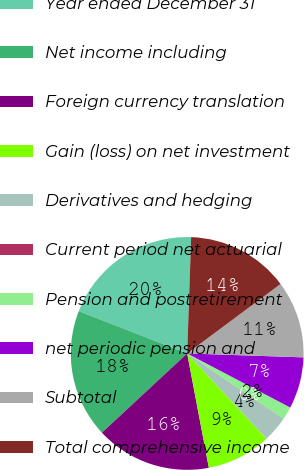<chart> <loc_0><loc_0><loc_500><loc_500><pie_chart><fcel>Year ended December 31<fcel>Net income including<fcel>Foreign currency translation<fcel>Gain (loss) on net investment<fcel>Derivatives and hedging<fcel>Current period net actuarial<fcel>Pension and postretirement<fcel>net periodic pension and<fcel>Subtotal<fcel>Total comprehensive income<nl><fcel>19.62%<fcel>17.84%<fcel>16.06%<fcel>8.93%<fcel>3.58%<fcel>0.02%<fcel>1.8%<fcel>7.15%<fcel>10.71%<fcel>14.28%<nl></chart> 